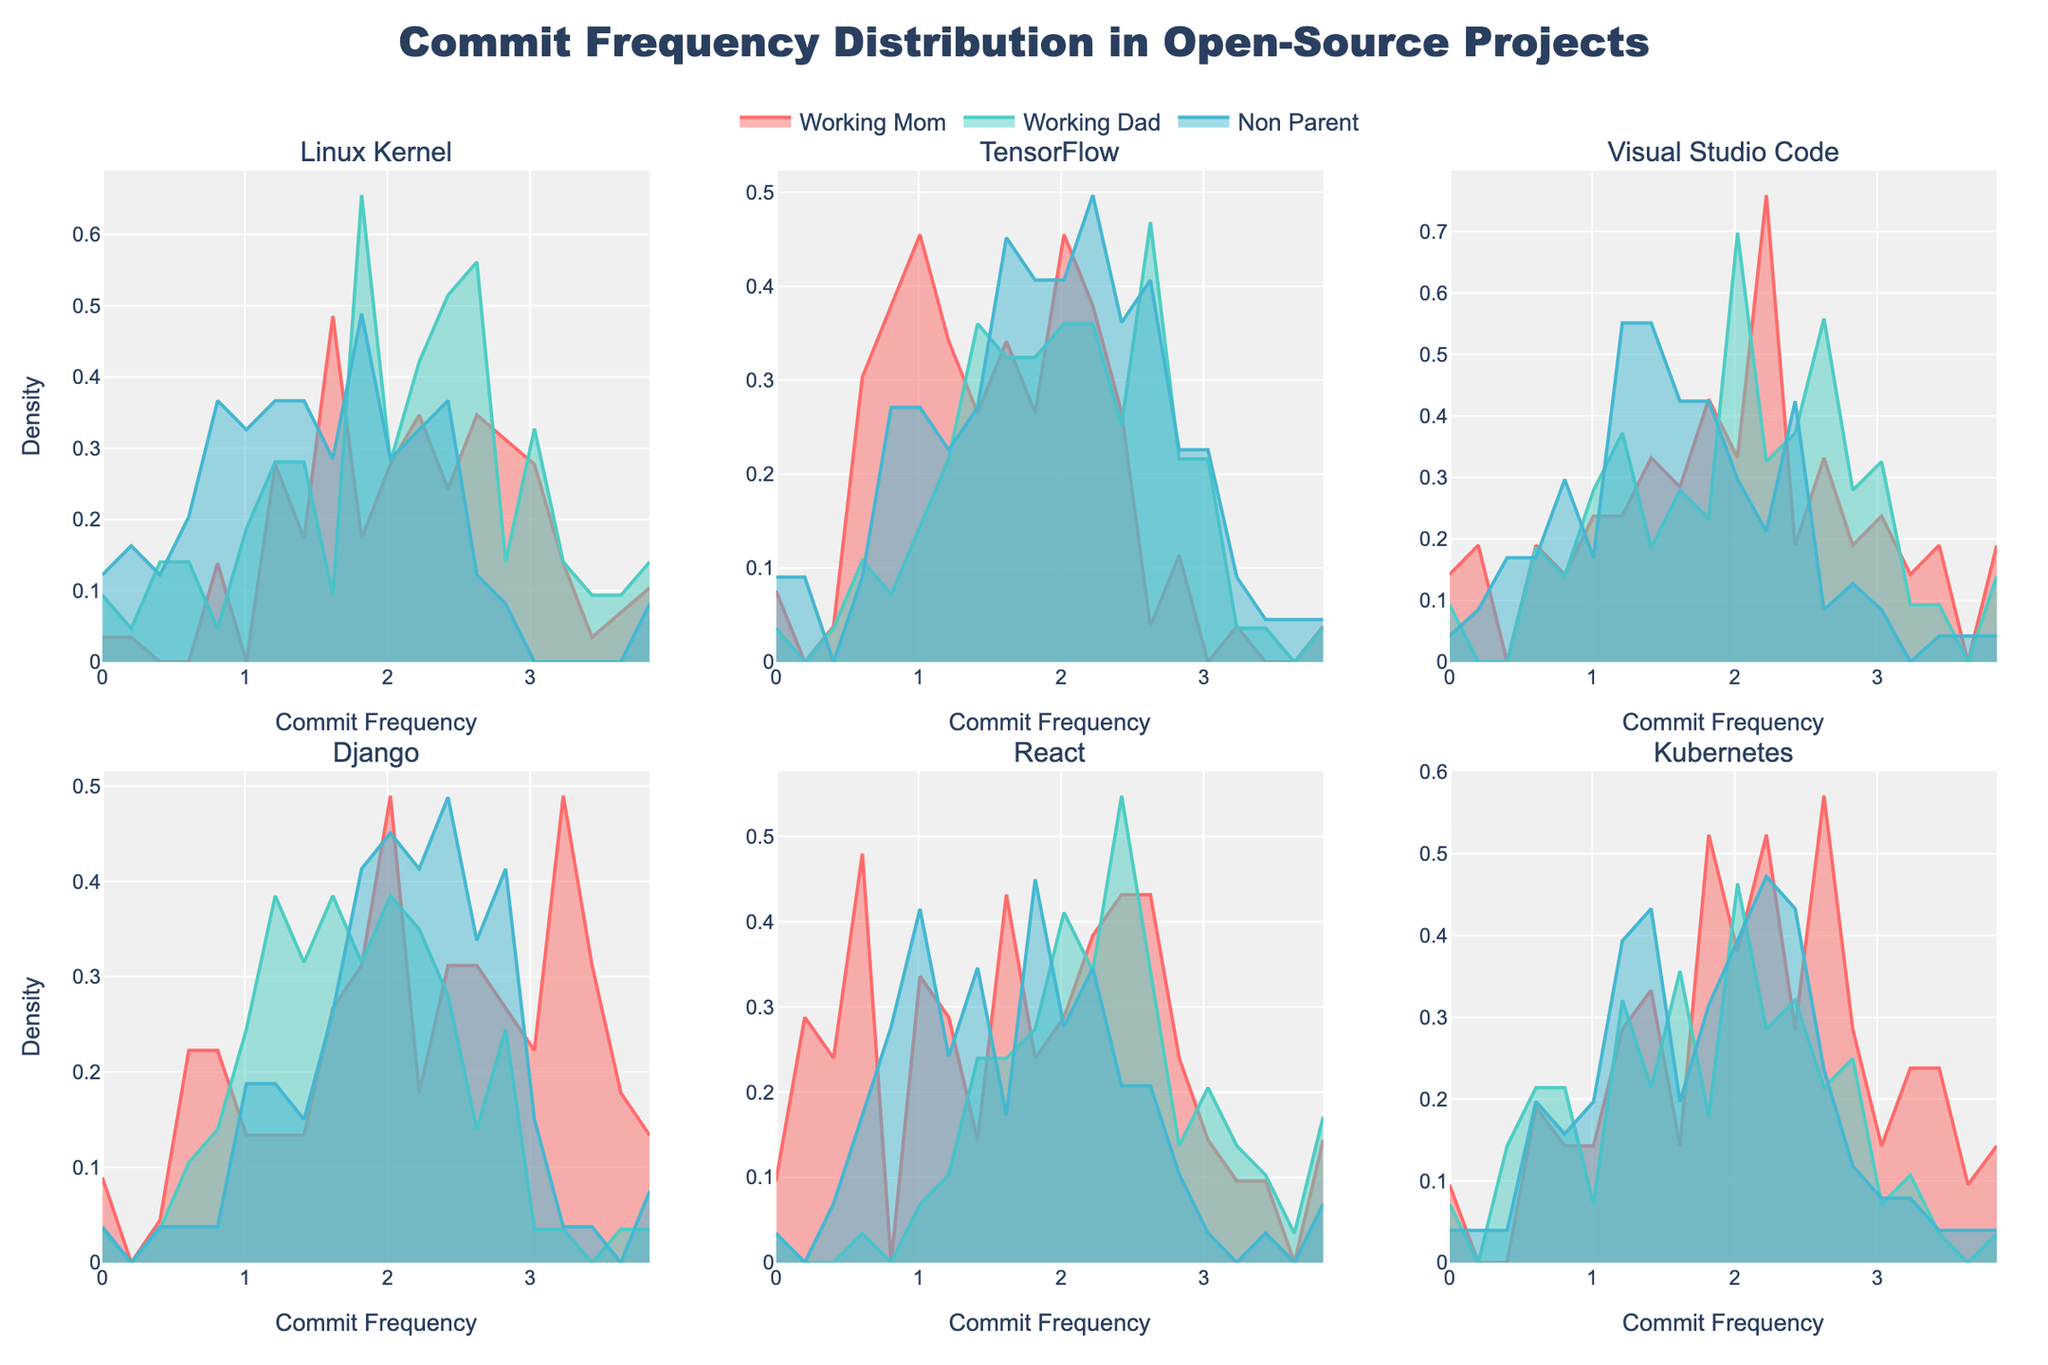What is the title of the figure? The title is prominently placed at the top of the figure, it reads "Commit Frequency Distribution in Open-Source Projects."
Answer: Commit Frequency Distribution in Open-Source Projects What are the labels for the X and Y axes? The X-axis is labeled "Commit Frequency" and the Y-axis is labeled "Density." These labels are visible under and next to the axes.
Answer: Commit Frequency, Density Which parent type has the highest peak density in the Django sub-plot? To determine the highest peak, look for the curve that reaches the highest point in the Django subplot. The "Non-Parent" curve reaches the highest density peak.
Answer: Non-Parent How does the commit frequency of working moms in the React project compare to that of working dads? In the React subplot, compare the peaks of the "Working Mom" and "Working Dad" density plots. The "Working Dad" density peak is at a higher commit frequency (12) than the "Working Mom" (10).
Answer: Working Dad has higher commit frequency Which project has the lowest commit frequency for working moms? By examining the density peaks in the subplots for each project, the subplot for Kubernetes shows the lowest peak at a commit frequency of 6 for working moms.
Answer: Kubernetes Is the commit frequency for non-parents consistent across all projects? Scan through the subplots for the "Non-Parent" density peaks. They all are somewhat close around commit frequencies of 10-18, indicating a consistent pattern.
Answer: Yes, it is consistent What can be inferred from the density distribution of working moms in the TensorFlow project? The TensorFlow subplot shows a lower peak for working moms around a commit frequency of 8. This suggests working moms contribute commits less frequently to TensorFlow compared to other projects.
Answer: Lower commit frequency Which parent type contributes most frequently to Visual Studio Code according to the figure? The subplot for Visual Studio Code shows the "Non-Parent" curve having the highest peak at a commit frequency of 13.
Answer: Non-Parent What's the difference in commit frequencies between non-parents in the Linux Kernel and Kubernetes projects? The Linux Kernel project shows a peak at commit frequency 18 for non-parents, while Kubernetes shows a peak at commit frequency 10. The difference is 18 - 10 = 8.
Answer: 8 How does the density of commit frequencies for working dads compare across the Django and Linux Kernel projects? Compare the density peaks for "Working Dad" in both subplots. Django has a peak at 9 while Linux Kernel has a peak at 15.
Answer: Higher in Linux Kernel 